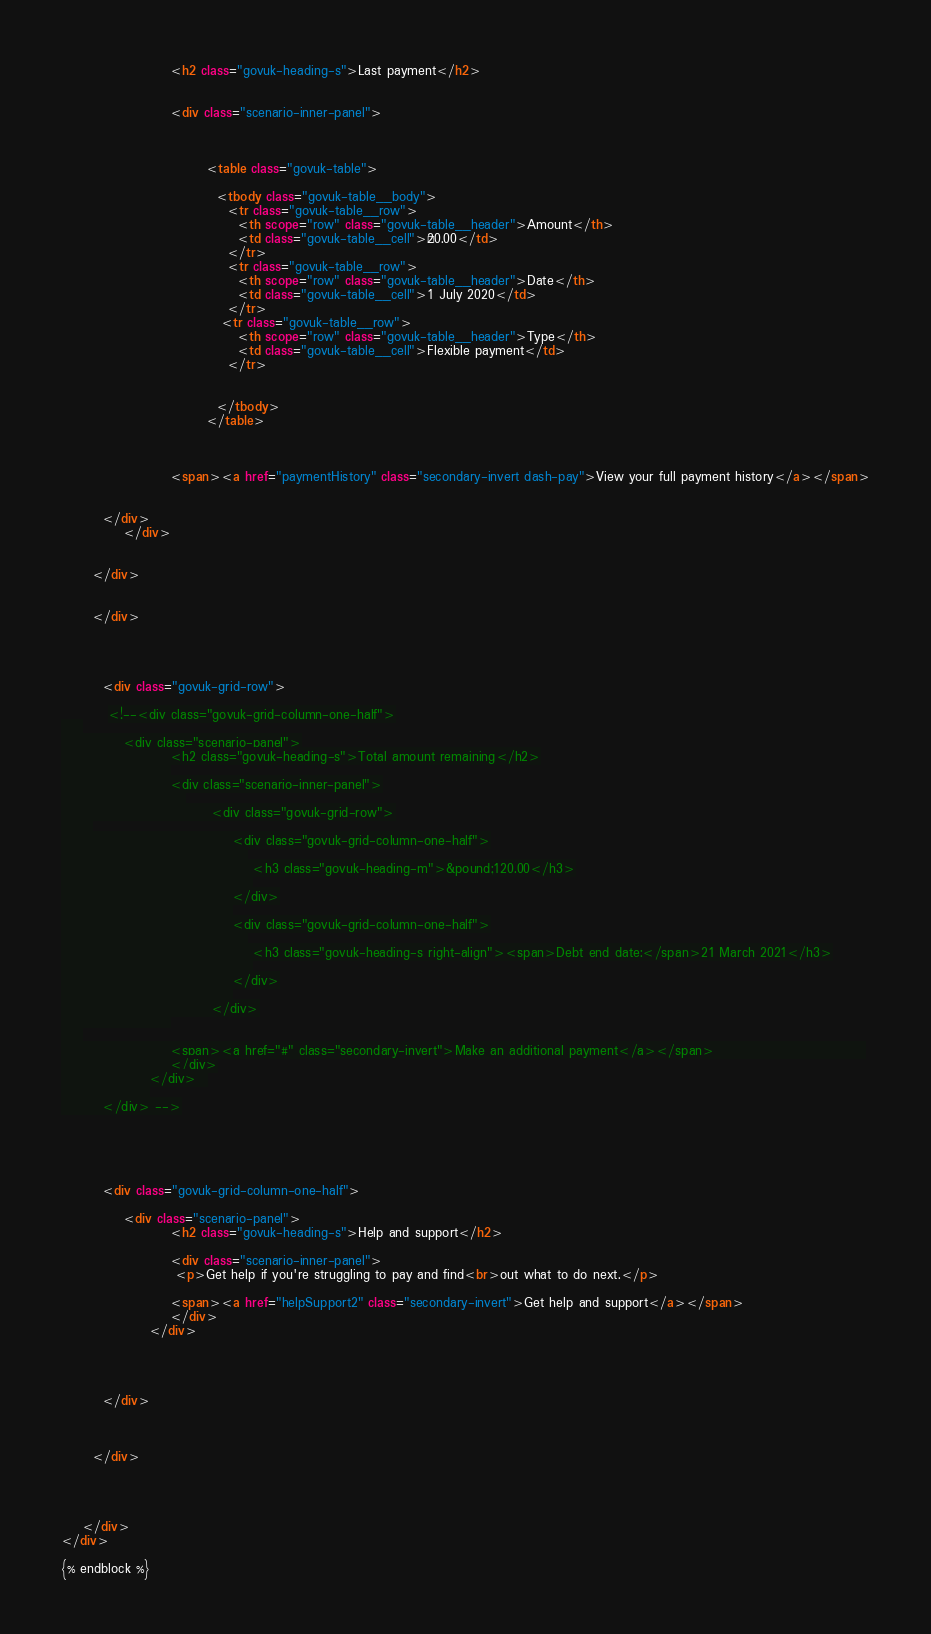<code> <loc_0><loc_0><loc_500><loc_500><_HTML_>					 <h2 class="govuk-heading-s">Last payment</h2>
					
					 
					 <div class="scenario-inner-panel">
			
					 	
					 			
					 		<table class="govuk-table">

							  <tbody class="govuk-table__body">
							    <tr class="govuk-table__row">
							      <th scope="row" class="govuk-table__header">Amount</th>
							      <td class="govuk-table__cell">£20.00</td>
							    </tr>
							    <tr class="govuk-table__row">
							      <th scope="row" class="govuk-table__header">Date</th>
							      <td class="govuk-table__cell">1 July 2020</td>
							    </tr>
							   <tr class="govuk-table__row">
							      <th scope="row" class="govuk-table__header">Type</th>
							      <td class="govuk-table__cell">Flexible payment</td>
							    </tr>

							   
							  </tbody>
							</table>
							
																
	
		             <span><a href="paymentHistory" class="secondary-invert dash-pay">View your full payment history</a></span>
	
				 
        </div>
		    </div>

        
      </div>

        
      </div>

        
        
        
        <div class="govuk-grid-row">
        
         <!--<div class="govuk-grid-column-one-half">
    
		    <div class="scenario-panel">
					 <h2 class="govuk-heading-s">Total amount remaining</h2>
					 
					 <div class="scenario-inner-panel">
					 	
					 		 <div class="govuk-grid-row">
      
						 		 <div class="govuk-grid-column-one-half">
						 		 	
						 		 	 <h3 class="govuk-heading-m">&pound;120.00</h3>
						 		 	 
						 		 </div>
						 		 
						 		 <div class="govuk-grid-column-one-half">
						 		 	
						 		 	 <h3 class="govuk-heading-s right-align"><span>Debt end date:</span>21 March 2021</h3>
						 		 	 
						 		 </div>
						 		 
					 		 </div>
					 
	
		             <span><a href="#" class="secondary-invert">Make an additional payment</a></span>	        	 	          
					 </div>
				 </div>	 
				 
        </div> -->
        
        
        
        
        
        <div class="govuk-grid-column-one-half">
    
		    <div class="scenario-panel">
					 <h2 class="govuk-heading-s">Help and support</h2>
					 
					 <div class="scenario-inner-panel">
					  <p>Get help if you're struggling to pay and find<br>out what to do next.</p>
					 
		             <span><a href="helpSupport2" class="secondary-invert">Get help and support</a></span> 
					 </div>
				 </div>	 
				 
				 
				
				 
        </div>

        
        
      </div>
      
     
      
            
    </div>
</div>

{% endblock %}
</code> 